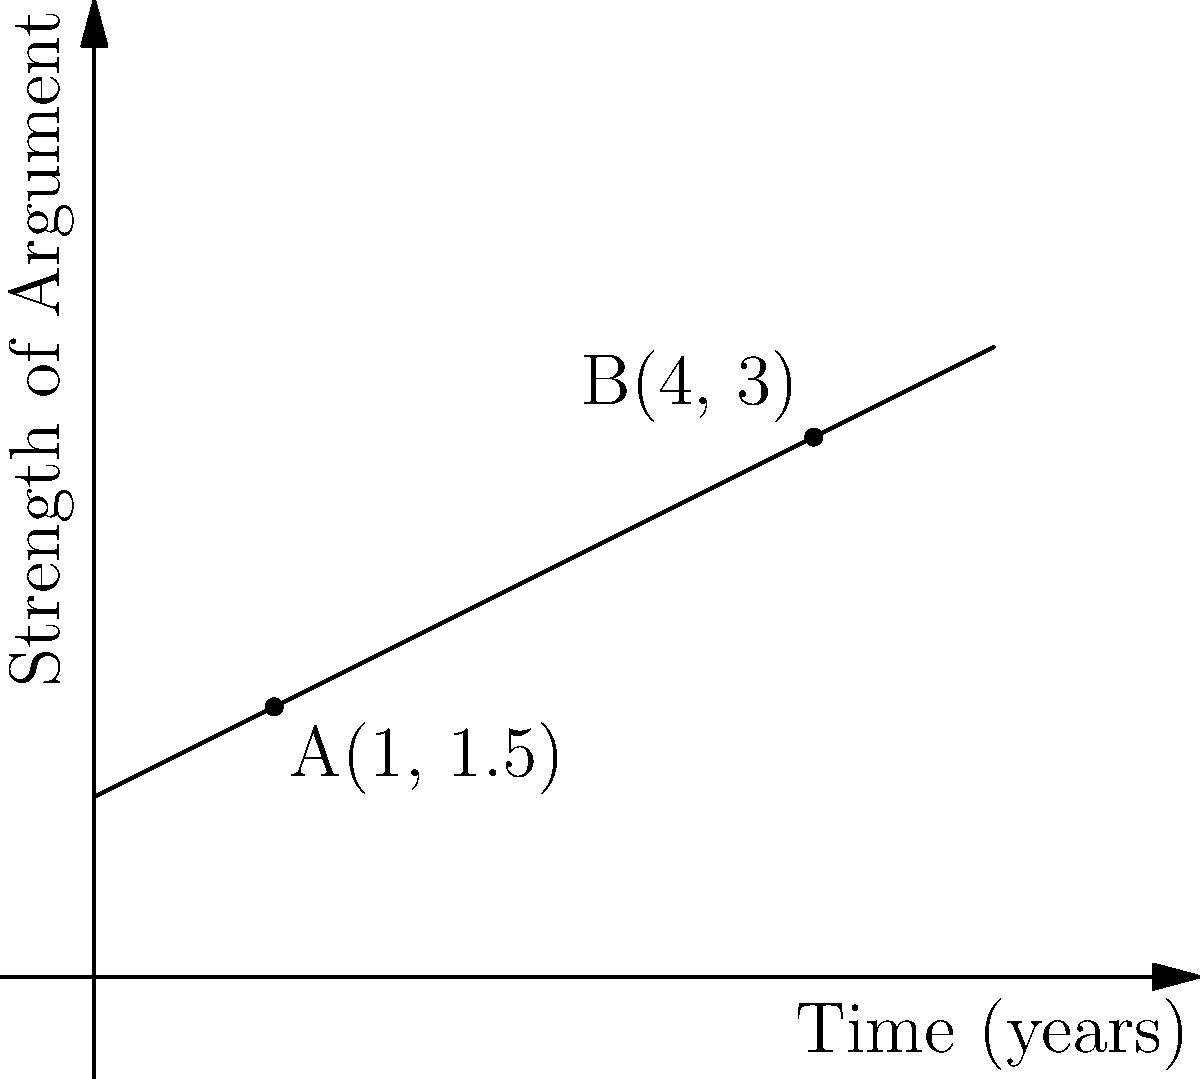In a landmark civil rights case, the strength of a legal argument is plotted against time. Two critical points in the case are represented by A(1, 1.5) and B(4, 3), where the x-axis represents years since the case began, and the y-axis represents the strength of the argument on a scale of 0 to 5. Calculate the slope of the line connecting these two points, which represents the rate at which the argument's strength increases over time. To calculate the slope of a line given two points, we use the formula:

$$ \text{slope} = \frac{y_2 - y_1}{x_2 - x_1} $$

Where $(x_1, y_1)$ is the first point and $(x_2, y_2)$ is the second point.

Given:
Point A: (1, 1.5)
Point B: (4, 3)

Step 1: Identify the coordinates
$x_1 = 1$, $y_1 = 1.5$
$x_2 = 4$, $y_2 = 3$

Step 2: Substitute these values into the slope formula
$$ \text{slope} = \frac{3 - 1.5}{4 - 1} = \frac{1.5}{3} $$

Step 3: Simplify the fraction
$$ \text{slope} = 0.5 $$

This means that for each year that passes, the strength of the legal argument increases by 0.5 units on the given scale.
Answer: 0.5 